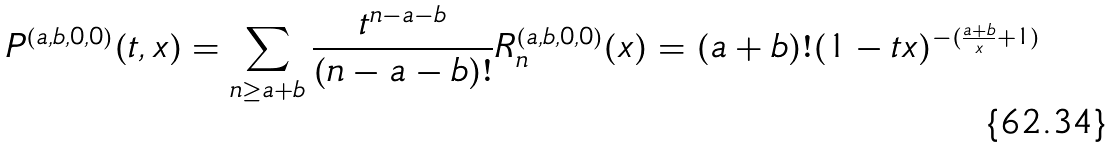<formula> <loc_0><loc_0><loc_500><loc_500>P ^ { ( a , b , 0 , 0 ) } ( t , x ) = \sum _ { n \geq a + b } \frac { t ^ { n - a - b } } { ( n - a - b ) ! } R _ { n } ^ { ( a , b , 0 , 0 ) } ( x ) = ( a + b ) ! ( 1 - t x ) ^ { - ( \frac { a + b } { x } + 1 ) }</formula> 